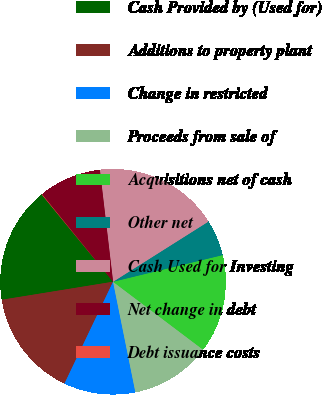<chart> <loc_0><loc_0><loc_500><loc_500><pie_chart><fcel>Cash Provided by (Used for)<fcel>Additions to property plant<fcel>Change in restricted<fcel>Proceeds from sale of<fcel>Acquisitions net of cash<fcel>Other net<fcel>Cash Used for Investing<fcel>Net change in debt<fcel>Debt issuance costs<nl><fcel>16.64%<fcel>15.36%<fcel>10.26%<fcel>11.54%<fcel>14.09%<fcel>5.16%<fcel>17.91%<fcel>8.99%<fcel>0.06%<nl></chart> 